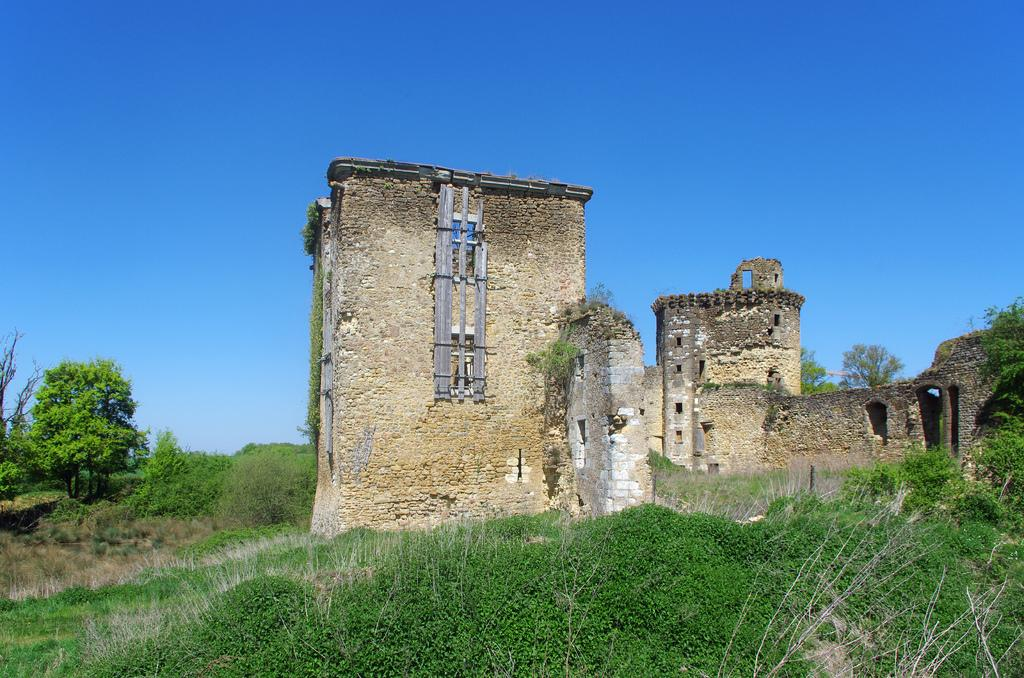What type of structure is visible in the image? There is a building in the image. What can be seen in the foreground of the image? There is a group of plants in the foreground of the image. What is visible in the background of the image? There are trees and the sky visible in the background of the image. Can you see a ghost arguing with the trees in the background of the image? No, there is no ghost or argument present in the image. The image features a building, plants in the foreground, and trees and sky in the background. 